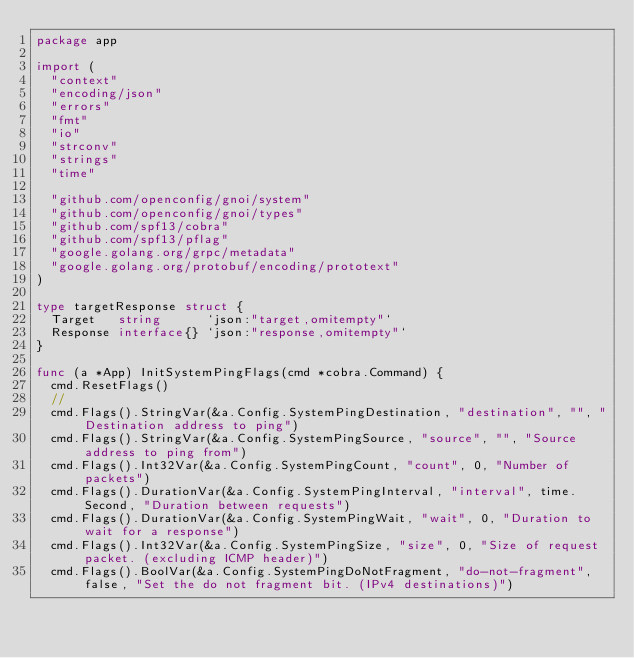<code> <loc_0><loc_0><loc_500><loc_500><_Go_>package app

import (
	"context"
	"encoding/json"
	"errors"
	"fmt"
	"io"
	"strconv"
	"strings"
	"time"

	"github.com/openconfig/gnoi/system"
	"github.com/openconfig/gnoi/types"
	"github.com/spf13/cobra"
	"github.com/spf13/pflag"
	"google.golang.org/grpc/metadata"
	"google.golang.org/protobuf/encoding/prototext"
)

type targetResponse struct {
	Target   string      `json:"target,omitempty"`
	Response interface{} `json:"response,omitempty"`
}

func (a *App) InitSystemPingFlags(cmd *cobra.Command) {
	cmd.ResetFlags()
	//
	cmd.Flags().StringVar(&a.Config.SystemPingDestination, "destination", "", "Destination address to ping")
	cmd.Flags().StringVar(&a.Config.SystemPingSource, "source", "", "Source address to ping from")
	cmd.Flags().Int32Var(&a.Config.SystemPingCount, "count", 0, "Number of packets")
	cmd.Flags().DurationVar(&a.Config.SystemPingInterval, "interval", time.Second, "Duration between requests")
	cmd.Flags().DurationVar(&a.Config.SystemPingWait, "wait", 0, "Duration to wait for a response")
	cmd.Flags().Int32Var(&a.Config.SystemPingSize, "size", 0, "Size of request packet. (excluding ICMP header)")
	cmd.Flags().BoolVar(&a.Config.SystemPingDoNotFragment, "do-not-fragment", false, "Set the do not fragment bit. (IPv4 destinations)")</code> 